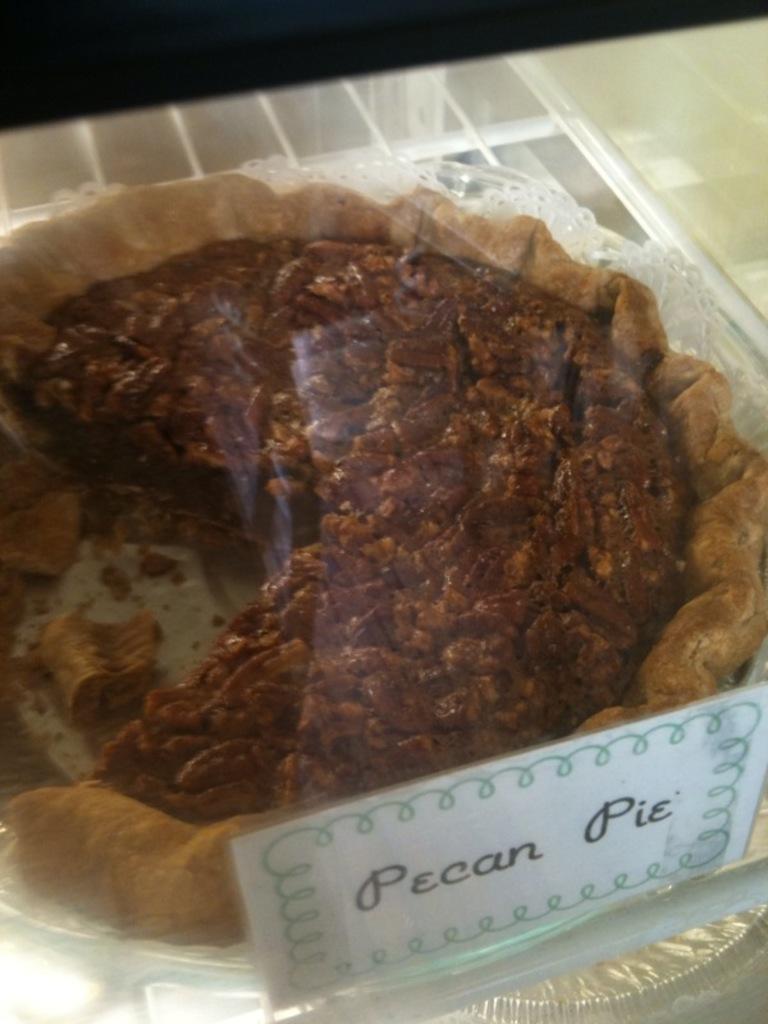How would you summarize this image in a sentence or two? In this picture we can see a glass in the front, there is a paper pasted on the glass, from the glass we can see pecan pie. 